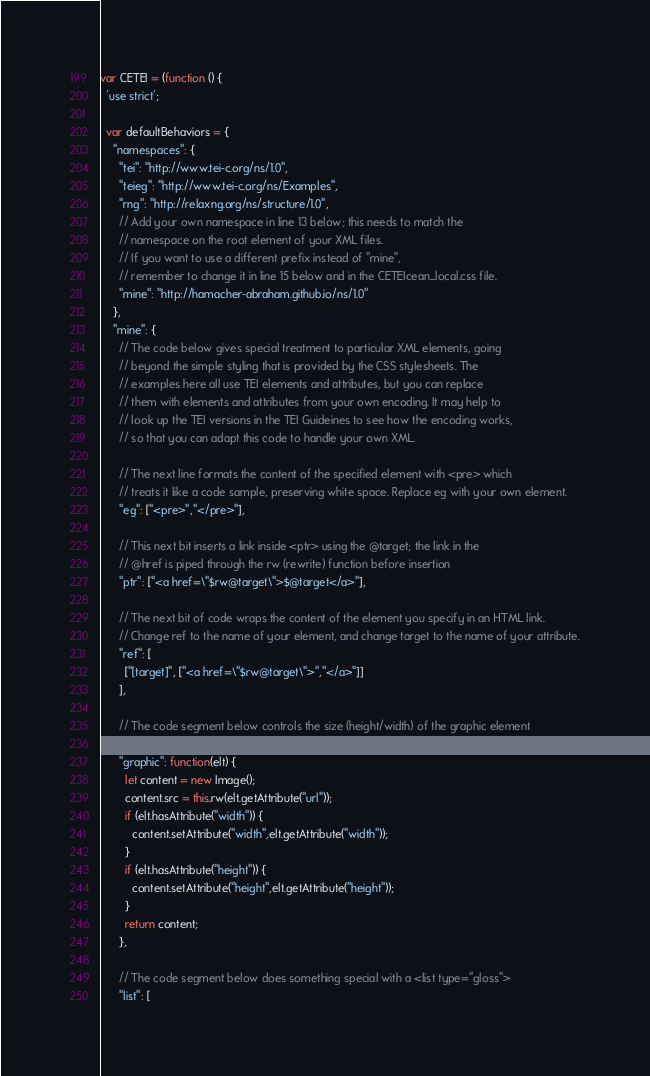<code> <loc_0><loc_0><loc_500><loc_500><_JavaScript_>var CETEI = (function () {
  'use strict';

  var defaultBehaviors = {
    "namespaces": {
      "tei": "http://www.tei-c.org/ns/1.0",
      "teieg": "http://www.tei-c.org/ns/Examples",
      "rng": "http://relaxng.org/ns/structure/1.0",
      // Add your own namespace in line 13 below; this needs to match the 
      // namespace on the root element of your XML files.
      // If you want to use a different prefix instead of "mine",
      // remember to change it in line 15 below and in the CETEIcean_local.css file.
      "mine": "http://hamacher-abraham.github.io/ns/1.0"
    },
    "mine": {
      // The code below gives special treatment to particular XML elements, going
      // beyond the simple styling that is provided by the CSS stylesheets. The
      // examples here all use TEI elements and attributes, but you can replace 
      // them with elements and attributes from your own encoding. It may help to
      // look up the TEI versions in the TEI Guideines to see how the encoding works,
      // so that you can adapt this code to handle your own XML.
      
      // The next line formats the content of the specified element with <pre> which
      // treats it like a code sample, preserving white space. Replace eg with your own element.
      "eg": ["<pre>","</pre>"],

      // This next bit inserts a link inside <ptr> using the @target; the link in the
      // @href is piped through the rw (rewrite) function before insertion
      "ptr": ["<a href=\"$rw@target\">$@target</a>"],

      // The next bit of code wraps the content of the element you specify in an HTML link.
      // Change ref to the name of your element, and change target to the name of your attribute.
      "ref": [
        ["[target]", ["<a href=\"$rw@target\">","</a>"]]
      ],
      
      // The code segment below controls the size (height/width) of the graphic element

      "graphic": function(elt) {
        let content = new Image();
        content.src = this.rw(elt.getAttribute("url"));
        if (elt.hasAttribute("width")) {
          content.setAttribute("width",elt.getAttribute("width"));
        }
        if (elt.hasAttribute("height")) {
          content.setAttribute("height",elt.getAttribute("height"));
        }
        return content;
      },
      
      // The code segment below does something special with a <list type="gloss">
      "list": [</code> 